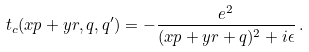Convert formula to latex. <formula><loc_0><loc_0><loc_500><loc_500>t _ { c } ( x p + y r , q , q ^ { \prime } ) = - \frac { e ^ { 2 } } { ( x p + y r + q ) ^ { 2 } + i \epsilon } \, .</formula> 